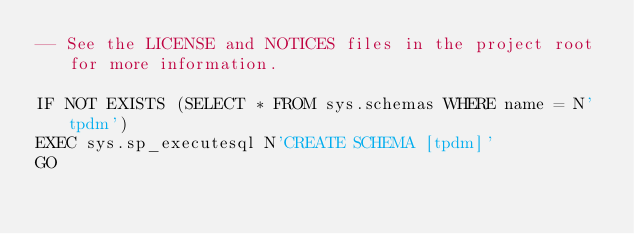Convert code to text. <code><loc_0><loc_0><loc_500><loc_500><_SQL_>-- See the LICENSE and NOTICES files in the project root for more information.

IF NOT EXISTS (SELECT * FROM sys.schemas WHERE name = N'tpdm')
EXEC sys.sp_executesql N'CREATE SCHEMA [tpdm]'
GO
</code> 